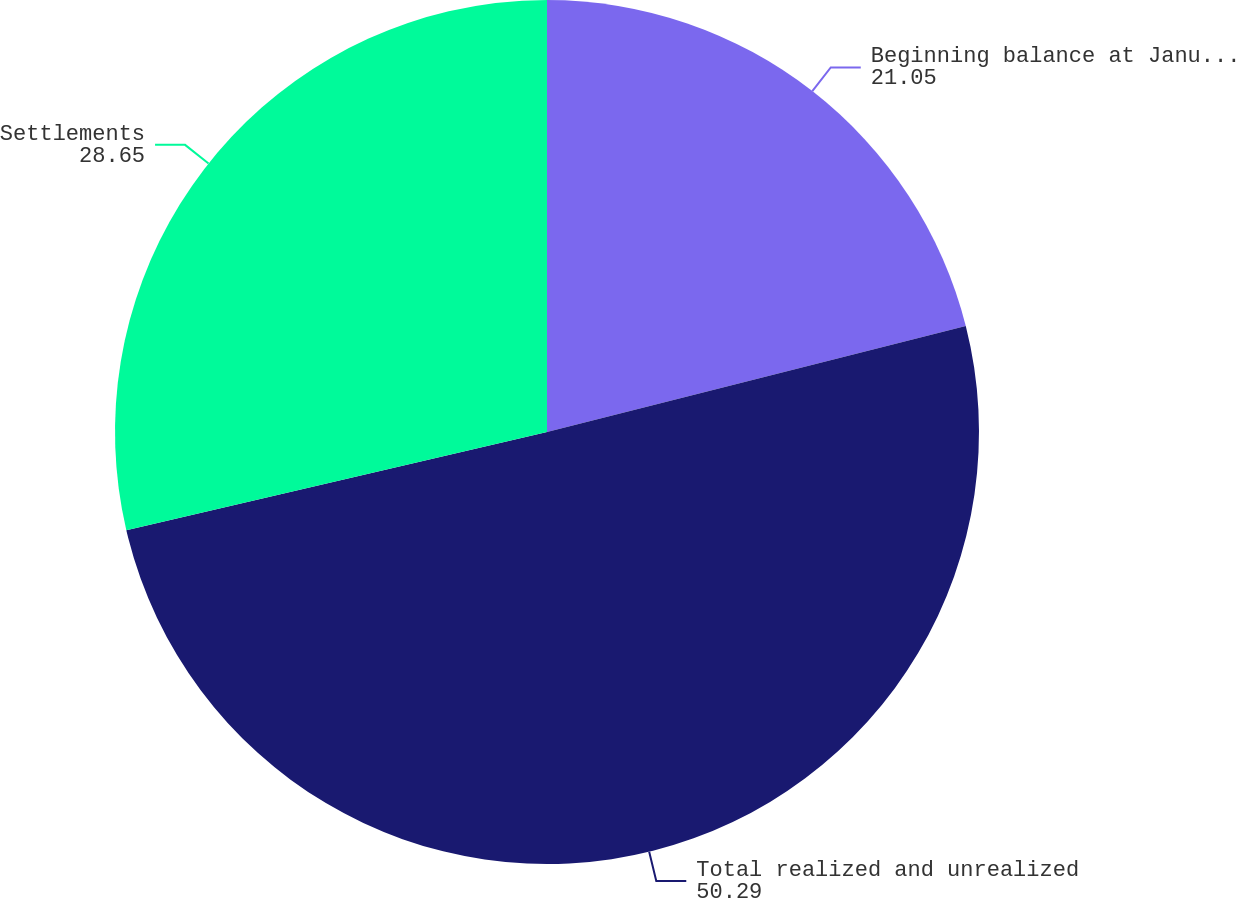Convert chart. <chart><loc_0><loc_0><loc_500><loc_500><pie_chart><fcel>Beginning balance at January 1<fcel>Total realized and unrealized<fcel>Settlements<nl><fcel>21.05%<fcel>50.29%<fcel>28.65%<nl></chart> 